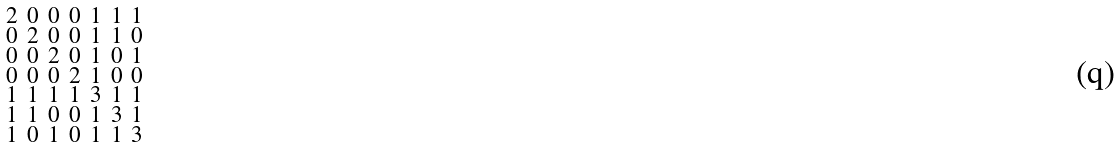<formula> <loc_0><loc_0><loc_500><loc_500>\begin{smallmatrix} 2 & 0 & 0 & 0 & 1 & 1 & 1 \\ 0 & 2 & 0 & 0 & 1 & 1 & 0 \\ 0 & 0 & 2 & 0 & 1 & 0 & 1 \\ 0 & 0 & 0 & 2 & 1 & 0 & 0 \\ 1 & 1 & 1 & 1 & 3 & 1 & 1 \\ 1 & 1 & 0 & 0 & 1 & 3 & 1 \\ 1 & 0 & 1 & 0 & 1 & 1 & 3 \end{smallmatrix}</formula> 